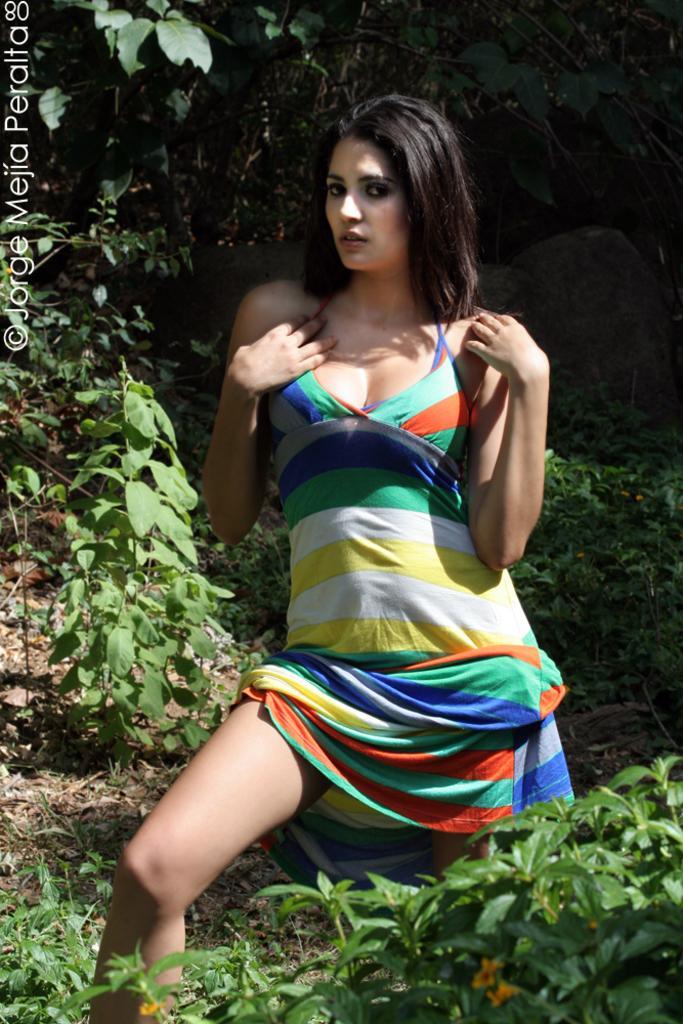Describe this image in one or two sentences. There is a woman standing. Near to her there are plants. On the left side there is a watermark. 